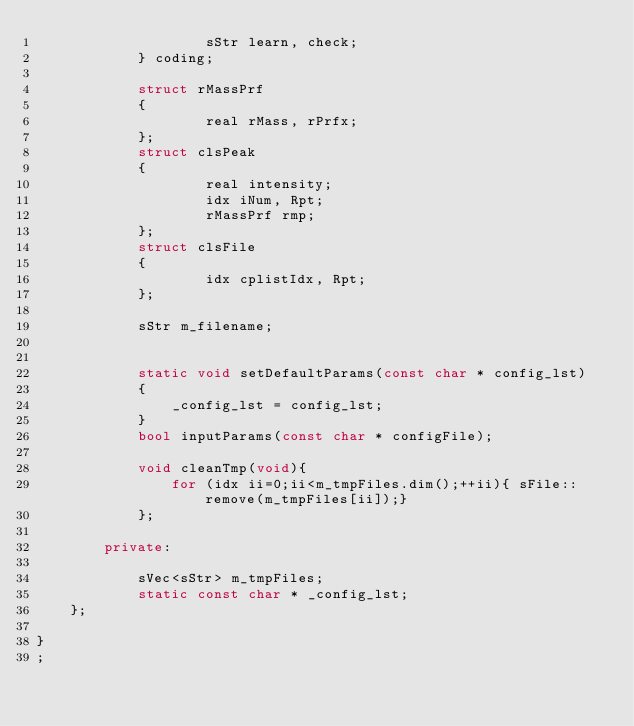Convert code to text. <code><loc_0><loc_0><loc_500><loc_500><_C++_>                    sStr learn, check;
            } coding;

            struct rMassPrf
            {
                    real rMass, rPrfx;
            };
            struct clsPeak
            {
                    real intensity;
                    idx iNum, Rpt;
                    rMassPrf rmp;
            };
            struct clsFile
            {
                    idx cplistIdx, Rpt;
            };

            sStr m_filename;


            static void setDefaultParams(const char * config_lst)
            {
                _config_lst = config_lst;
            }
            bool inputParams(const char * configFile);

            void cleanTmp(void){
                for (idx ii=0;ii<m_tmpFiles.dim();++ii){ sFile::remove(m_tmpFiles[ii]);}
            };

        private:

            sVec<sStr> m_tmpFiles;
            static const char * _config_lst;
    };

}
;

</code> 